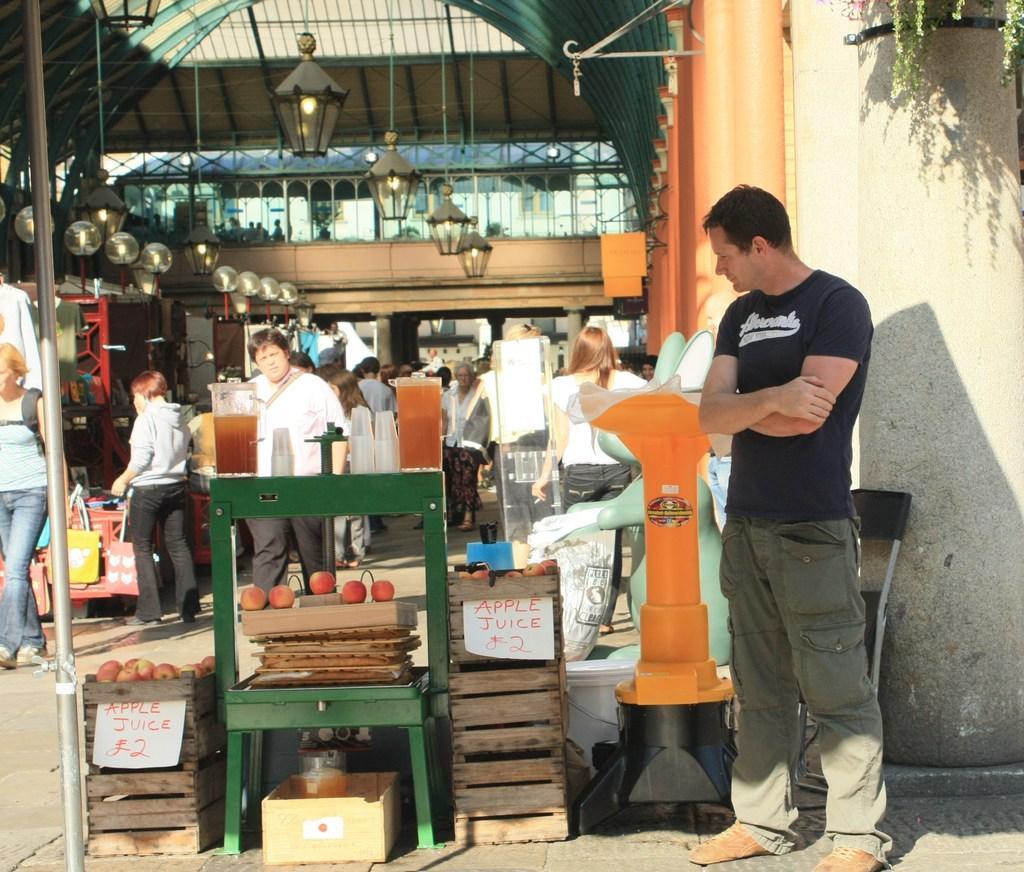In one or two sentences, can you explain what this image depicts? In this image there is a person standing, chair, there are apples in wooden trays, price boards, jars of juice in it , glasses on the table, and in the background there are group of people standing, lights , plant, iron rods. 